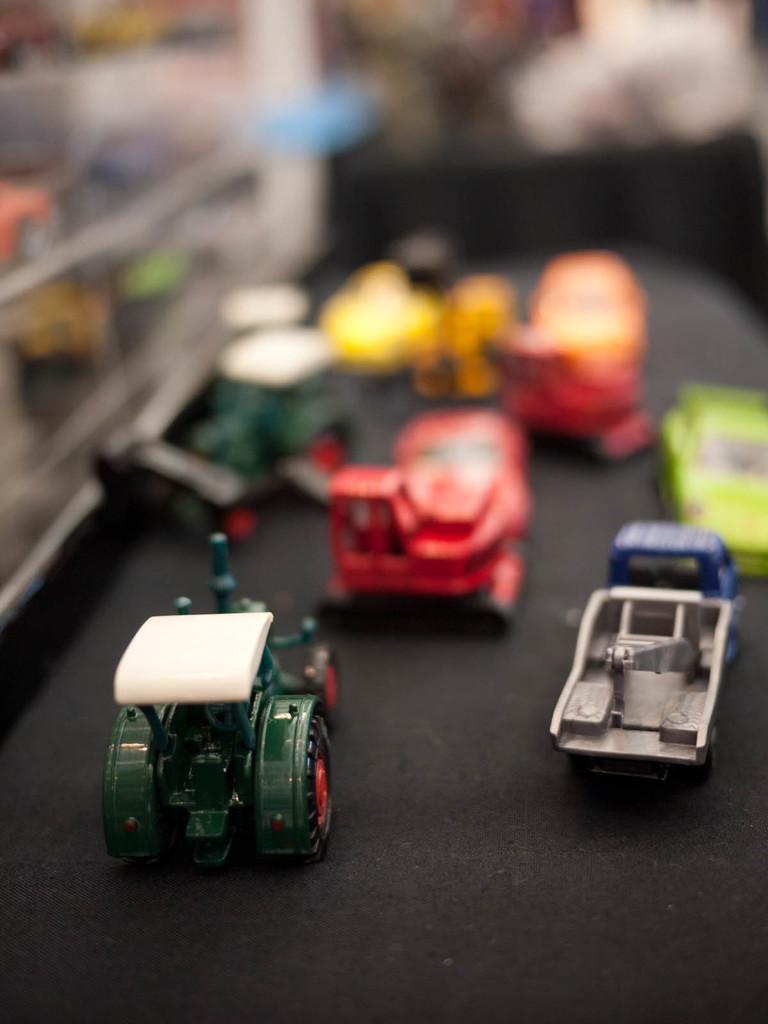In one or two sentences, can you explain what this image depicts? In this image we can see toys on a black surface. The background of the image is blurred. 